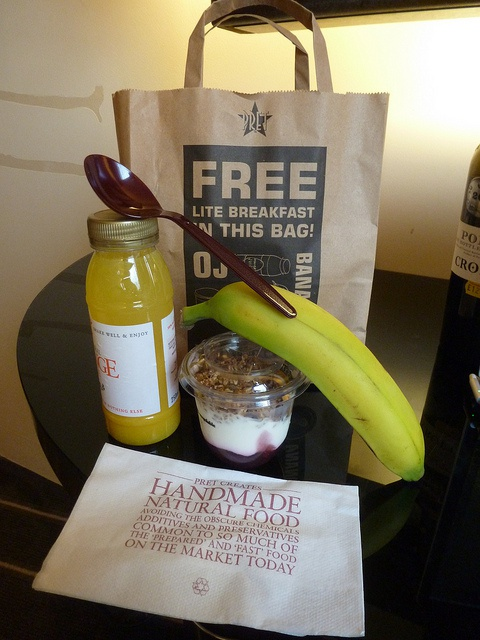Describe the objects in this image and their specific colors. I can see dining table in gray, black, olive, and lightgray tones, bottle in gray, olive, and lightblue tones, banana in gray, olive, and khaki tones, spoon in gray, black, and maroon tones, and bottle in gray, olive, black, and maroon tones in this image. 